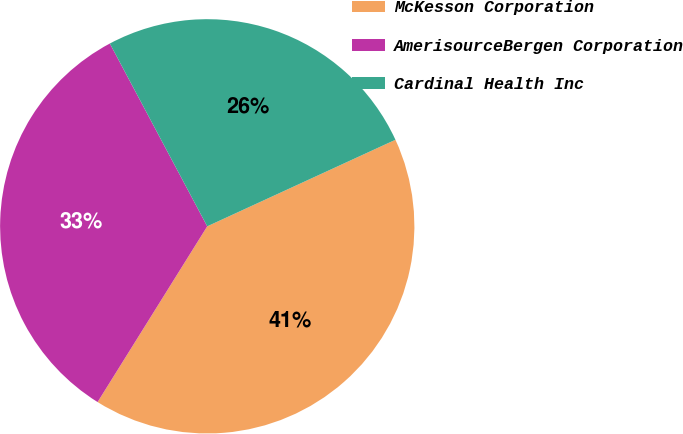Convert chart to OTSL. <chart><loc_0><loc_0><loc_500><loc_500><pie_chart><fcel>McKesson Corporation<fcel>AmerisourceBergen Corporation<fcel>Cardinal Health Inc<nl><fcel>40.74%<fcel>33.33%<fcel>25.93%<nl></chart> 